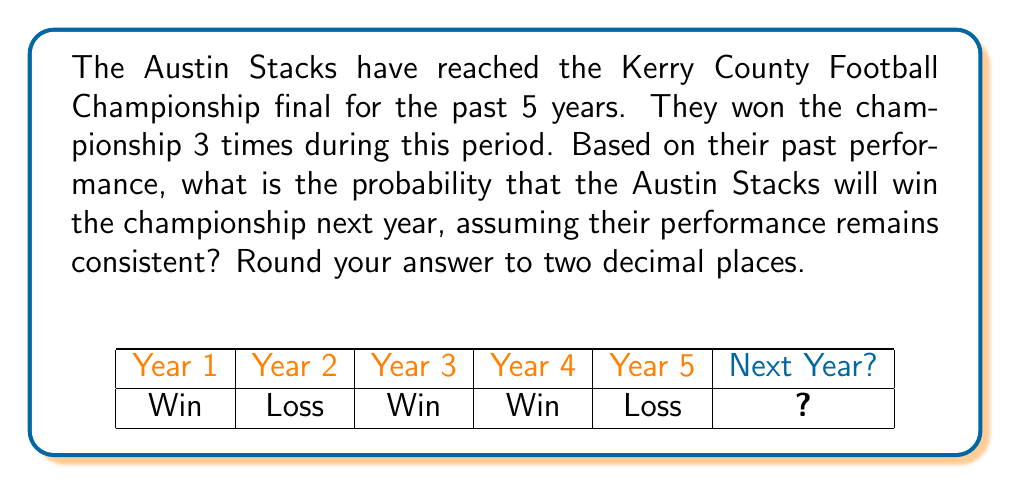Give your solution to this math problem. To calculate the probability of the Austin Stacks winning the championship next year based on their past performance, we can use the concept of relative frequency as an estimate of probability.

Step 1: Identify the relevant data
- Total number of years considered: 5
- Number of championship wins: 3

Step 2: Calculate the relative frequency
The relative frequency is given by:

$$ P(\text{win}) = \frac{\text{Number of favorable outcomes}}{\text{Total number of trials}} $$

In this case:
$$ P(\text{win}) = \frac{3}{5} = 0.6 $$

Step 3: Convert to a percentage and round
0.6 × 100% = 60%

Therefore, based on their past performance, there is a 60% (or 0.60 when expressed as a decimal) probability that the Austin Stacks will win the championship next year, assuming their performance remains consistent.
Answer: 0.60 